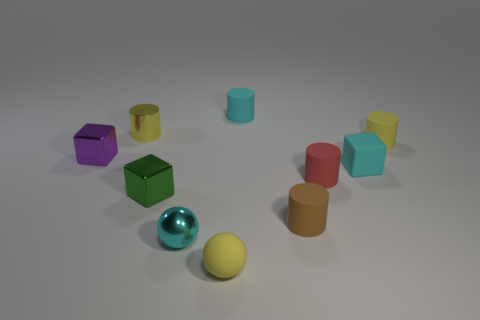What material is the other cylinder that is the same color as the small shiny cylinder?
Ensure brevity in your answer.  Rubber. How many objects are small red objects or big gray objects?
Your answer should be very brief. 1. There is a matte object right of the tiny rubber cube; does it have the same shape as the small purple object?
Provide a succinct answer. No. What color is the rubber object that is on the left side of the cyan matte thing that is behind the tiny purple metallic block?
Keep it short and to the point. Yellow. Is the number of tiny purple metallic blocks less than the number of large matte spheres?
Keep it short and to the point. No. Is there a big block that has the same material as the red cylinder?
Your answer should be compact. No. There is a tiny cyan metal thing; is its shape the same as the yellow object that is in front of the brown thing?
Give a very brief answer. Yes. There is a tiny cyan ball; are there any yellow rubber things behind it?
Provide a succinct answer. Yes. How many other metallic objects are the same shape as the cyan shiny object?
Ensure brevity in your answer.  0. Is the material of the yellow ball the same as the small brown cylinder that is in front of the tiny purple thing?
Provide a short and direct response. Yes. 